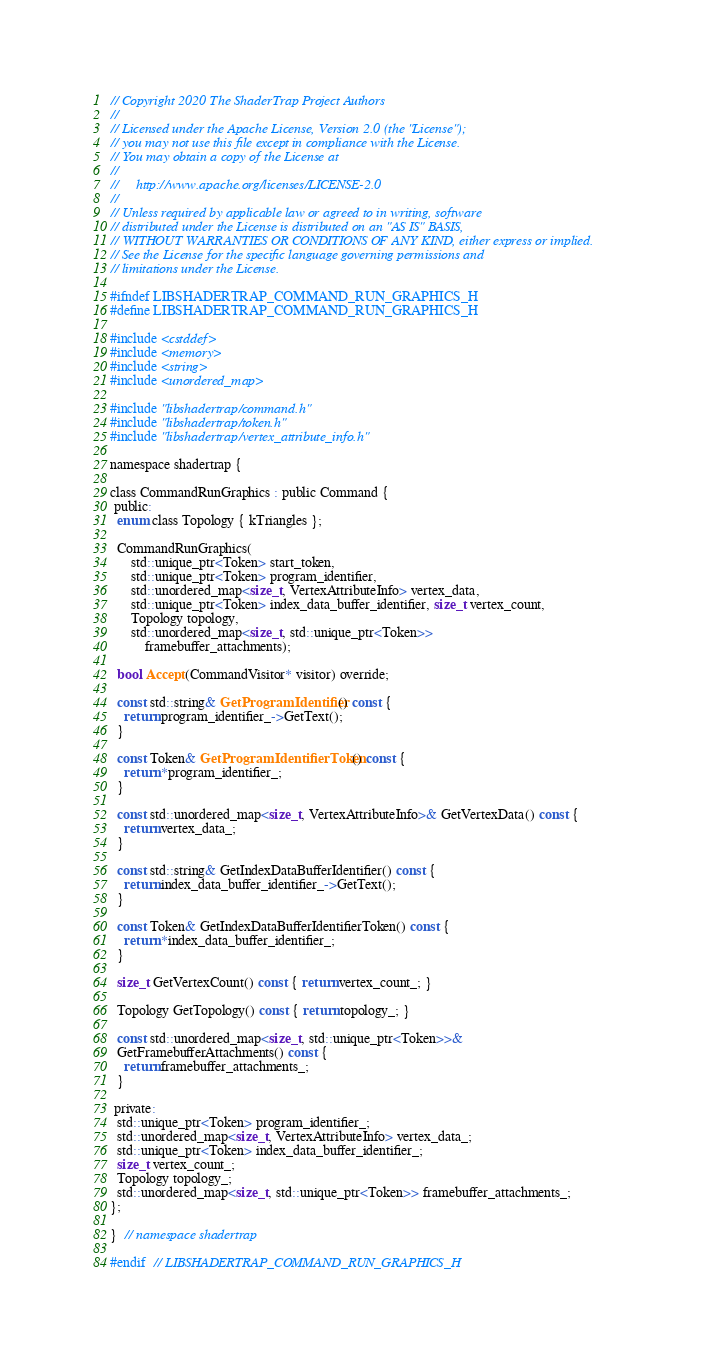Convert code to text. <code><loc_0><loc_0><loc_500><loc_500><_C_>// Copyright 2020 The ShaderTrap Project Authors
//
// Licensed under the Apache License, Version 2.0 (the "License");
// you may not use this file except in compliance with the License.
// You may obtain a copy of the License at
//
//     http://www.apache.org/licenses/LICENSE-2.0
//
// Unless required by applicable law or agreed to in writing, software
// distributed under the License is distributed on an "AS IS" BASIS,
// WITHOUT WARRANTIES OR CONDITIONS OF ANY KIND, either express or implied.
// See the License for the specific language governing permissions and
// limitations under the License.

#ifndef LIBSHADERTRAP_COMMAND_RUN_GRAPHICS_H
#define LIBSHADERTRAP_COMMAND_RUN_GRAPHICS_H

#include <cstddef>
#include <memory>
#include <string>
#include <unordered_map>

#include "libshadertrap/command.h"
#include "libshadertrap/token.h"
#include "libshadertrap/vertex_attribute_info.h"

namespace shadertrap {

class CommandRunGraphics : public Command {
 public:
  enum class Topology { kTriangles };

  CommandRunGraphics(
      std::unique_ptr<Token> start_token,
      std::unique_ptr<Token> program_identifier,
      std::unordered_map<size_t, VertexAttributeInfo> vertex_data,
      std::unique_ptr<Token> index_data_buffer_identifier, size_t vertex_count,
      Topology topology,
      std::unordered_map<size_t, std::unique_ptr<Token>>
          framebuffer_attachments);

  bool Accept(CommandVisitor* visitor) override;

  const std::string& GetProgramIdentifier() const {
    return program_identifier_->GetText();
  }

  const Token& GetProgramIdentifierToken() const {
    return *program_identifier_;
  }

  const std::unordered_map<size_t, VertexAttributeInfo>& GetVertexData() const {
    return vertex_data_;
  }

  const std::string& GetIndexDataBufferIdentifier() const {
    return index_data_buffer_identifier_->GetText();
  }

  const Token& GetIndexDataBufferIdentifierToken() const {
    return *index_data_buffer_identifier_;
  }

  size_t GetVertexCount() const { return vertex_count_; }

  Topology GetTopology() const { return topology_; }

  const std::unordered_map<size_t, std::unique_ptr<Token>>&
  GetFramebufferAttachments() const {
    return framebuffer_attachments_;
  }

 private:
  std::unique_ptr<Token> program_identifier_;
  std::unordered_map<size_t, VertexAttributeInfo> vertex_data_;
  std::unique_ptr<Token> index_data_buffer_identifier_;
  size_t vertex_count_;
  Topology topology_;
  std::unordered_map<size_t, std::unique_ptr<Token>> framebuffer_attachments_;
};

}  // namespace shadertrap

#endif  // LIBSHADERTRAP_COMMAND_RUN_GRAPHICS_H
</code> 